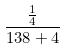<formula> <loc_0><loc_0><loc_500><loc_500>\frac { \frac { 1 } { 4 } } { 1 3 8 + 4 }</formula> 